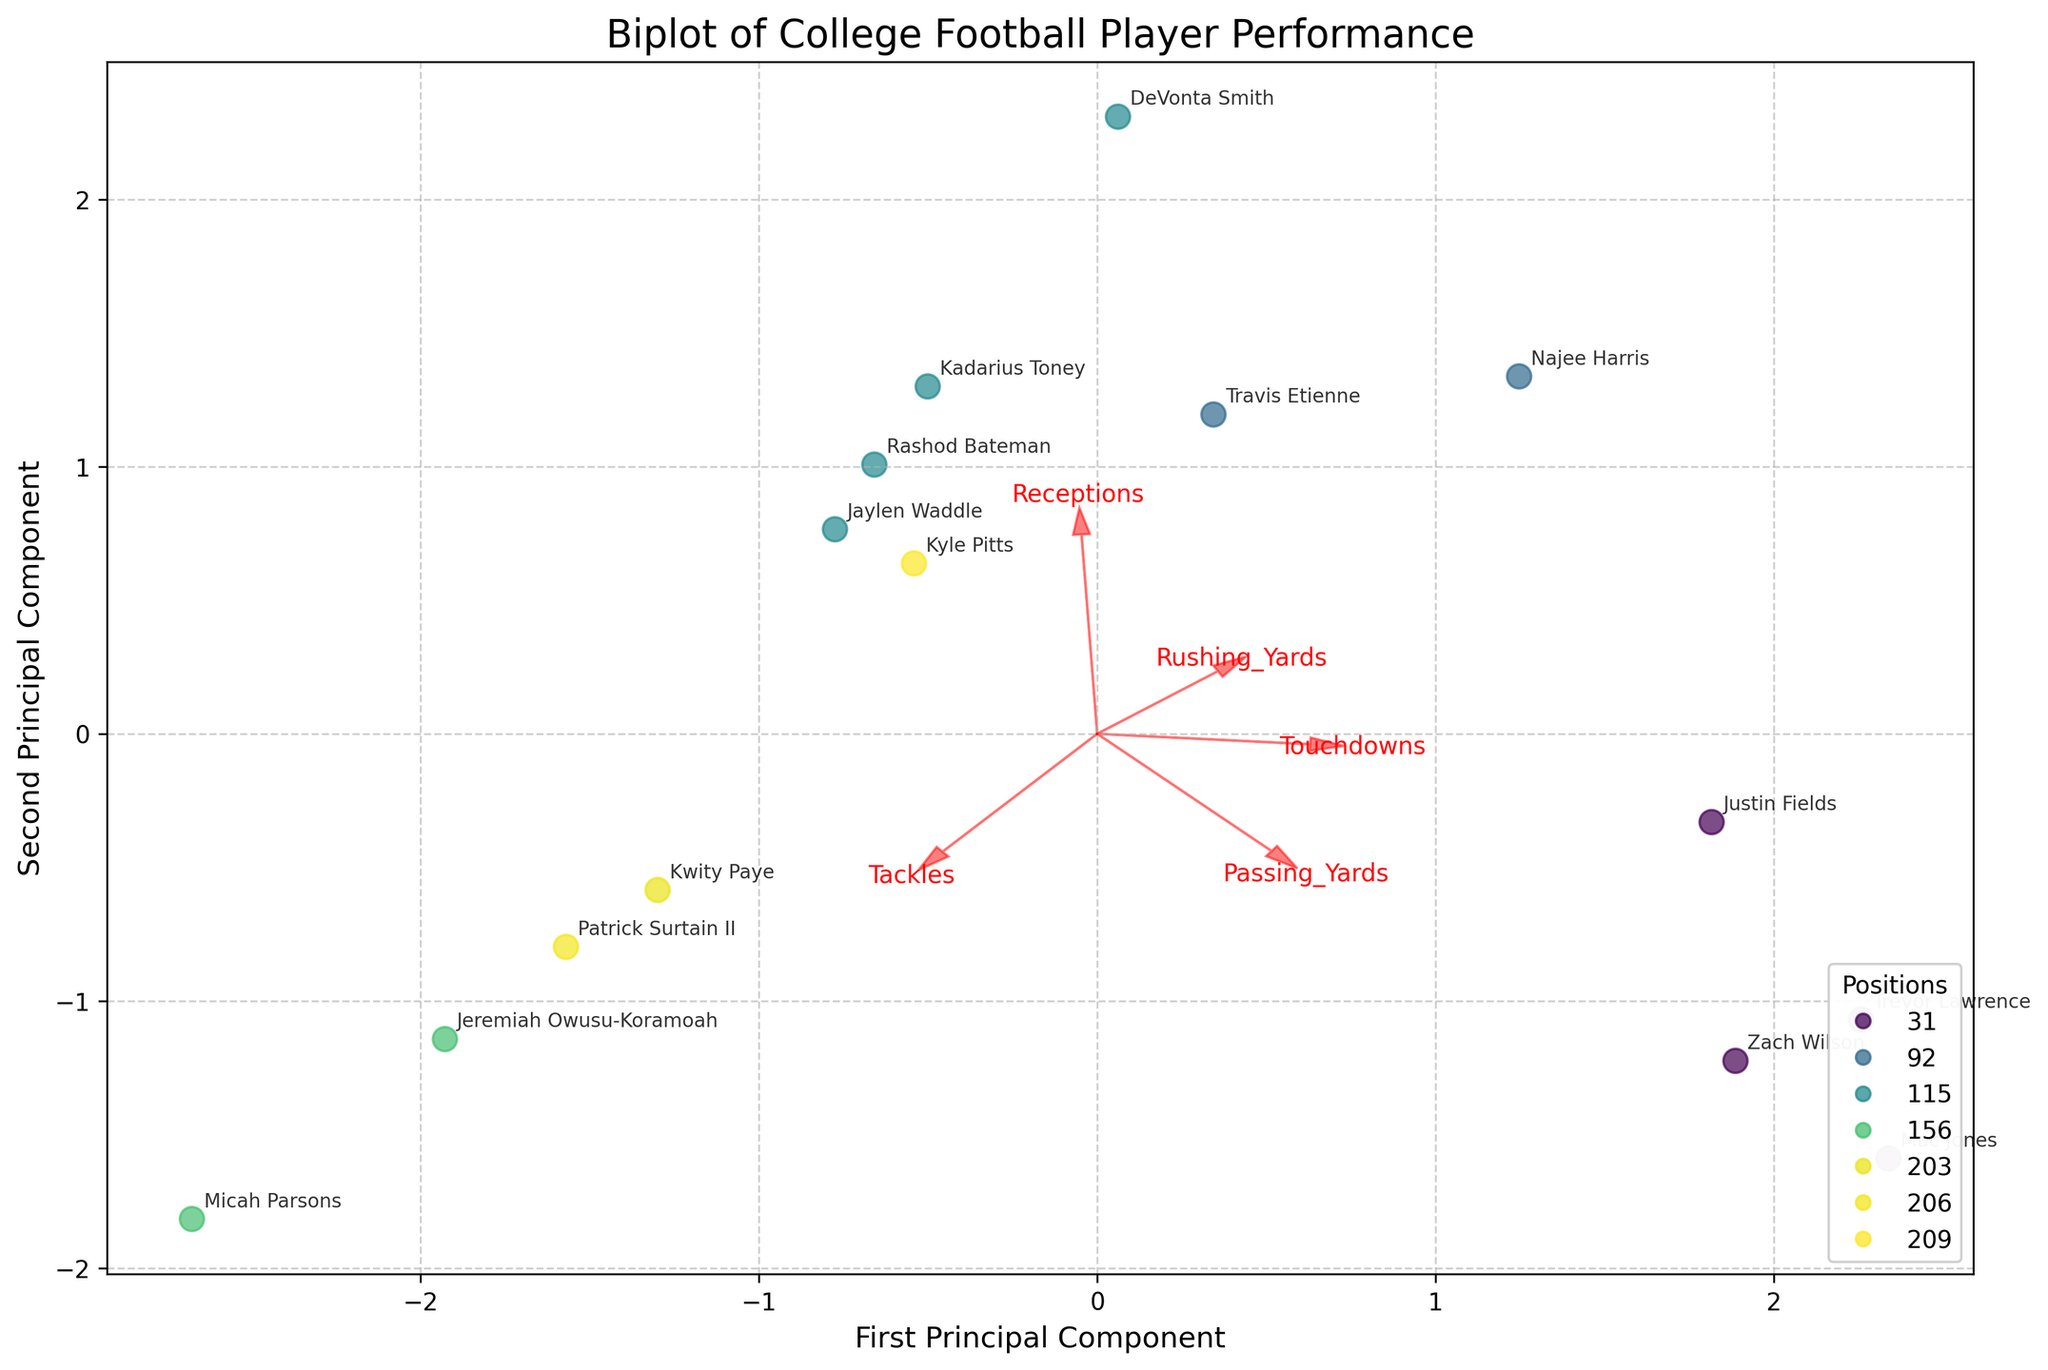What are the labels of the axes? The labels of the axes are usually indicated next to the axes themselves. Here, it says "First Principal Component" on the x-axis and "Second Principal Component" on the y-axis.
Answer: 'First Principal Component' and 'Second Principal Component' How many different positional groups are represented in the biplot? The different positional groups can be identified by the varying colors of the scatter points in the figure legend. Each color represents a unique position. By counting the legends, you can determine the number of positional groups.
Answer: 7 Which player has the highest value along the First Principal Component? By observing the scatter points on the x-axis, the player furthest to the right will have the highest value along the First Principal Component. Look at the annotation near this point.
Answer: Mac Jones Which feature vector has the greatest positive influence on the Second Principal Component? Feature vectors are represented by the red arrows, and their influence on components can be observed by their direction and length. The arrow which has the largest projection on the Second Principal Component (y-axis) determines the greatest positive influence.
Answer: Rushing_Yards Are quarterbacks (QBs) more spread out along the First or Second Principal Component? By locating the positions marked as QBs in the figure, observe their spread along the x-axis (First Principal Component) and y-axis (Second Principal Component). Compare the spread (variance) visually to answer this.
Answer: First Principal Component Which player is closest to the origin (0,0) in the biplot? Locate the scatter point that is nearest to the origin of the plot by tracking its annotation. This point represents the player closest to (0,0).
Answer: Micah Parsons Which two positions have players that overlap the most in the biplot? By identifying clusters of points with annotations belonging to different positions, determine which positions seem to share the most overlap. This can be done by visual inspection of the proximity of points from different positions.
Answer: WR and TE What can you infer about the features of Kyle Pitts based on his position in the biplot? Kyle Pitts' position relative to vectors gives an indication of his performance. Nearby arrows denote high values in specific metrics, and his closeness to their direction implies high performance in those areas. Compare his location to features like 'Receptions,' 'Touchdowns,' etc.
Answer: High in Receptions and moderate in Touchdowns Based on the biplot, which feature most strongly differentiates linebackers (LBs) from other positions? Look at the distribution of LB players relative to the feature vectors. The feature vector pointing in the direction where LBs are clustered can be inferred as the differentiating feature.
Answer: Tackles Between rushing yards and passing yards, which metric shows more distinction among players in the scatterplot? Observe the feature vectors for Rushing_Yards and Passing_Yards. The larger spread of players along the direction of either vector shows which metric more clearly differentiates the players.
Answer: Passing_Yards 